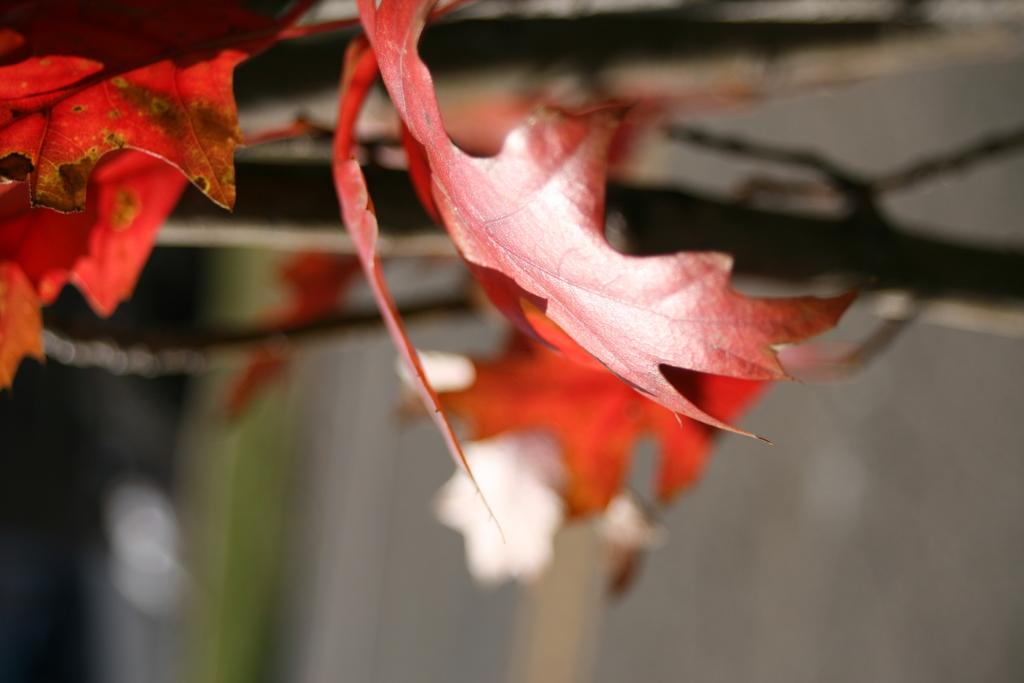What type of leaves can be seen on the branches in the image? There are red color maple leaves on the branches in the image. Can you describe the background of the image? The background of the image is blurred. What is the taste of the tank in the image? There is no tank present in the image, and therefore no taste can be associated with it. What type of joke is being told by the leaves in the image? There is no joke being told by the leaves in the image; they are simply red color maple leaves on the branches. 